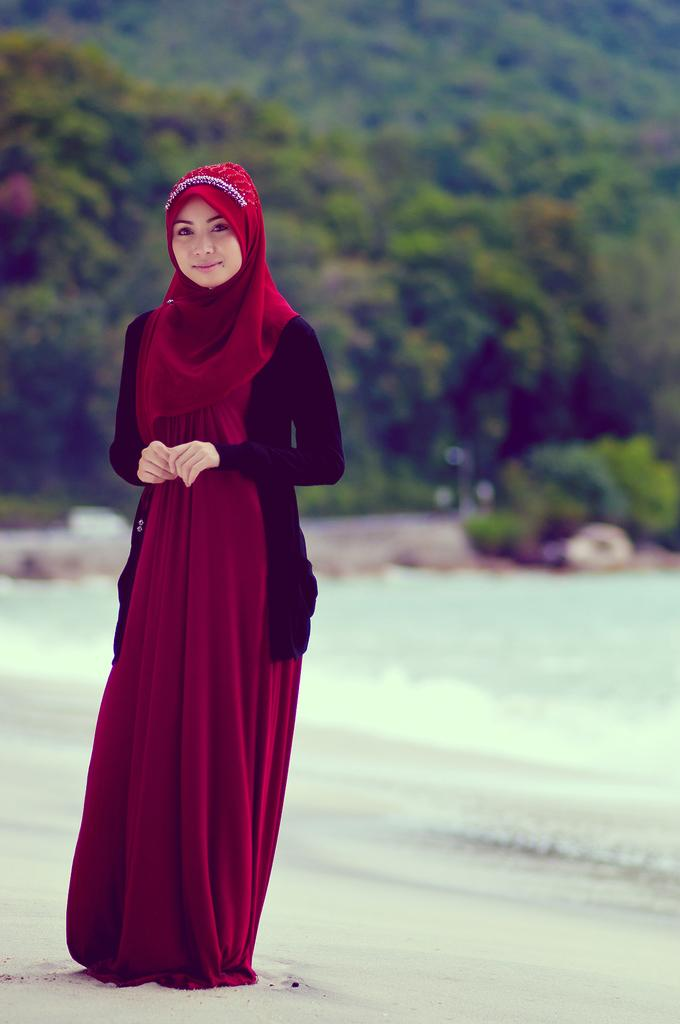Who is the main subject in the image? There is a girl in the image. Where is the girl located in the image? The girl is on the left side of the image. What can be seen in the background of the image? There is greenery in the background of the image. What type of rings does the girl have on her fingers in the image? There is no mention of rings in the image, so it cannot be determined if the girl is wearing any. 